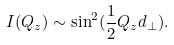Convert formula to latex. <formula><loc_0><loc_0><loc_500><loc_500>I ( Q _ { z } ) \sim \sin ^ { 2 } ( { \frac { 1 } { 2 } } Q _ { z } d _ { \bot } ) .</formula> 